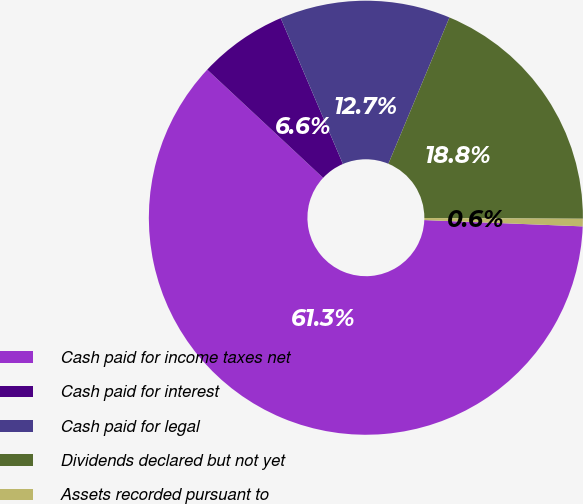Convert chart. <chart><loc_0><loc_0><loc_500><loc_500><pie_chart><fcel>Cash paid for income taxes net<fcel>Cash paid for interest<fcel>Cash paid for legal<fcel>Dividends declared but not yet<fcel>Assets recorded pursuant to<nl><fcel>61.31%<fcel>6.63%<fcel>12.71%<fcel>18.78%<fcel>0.56%<nl></chart> 